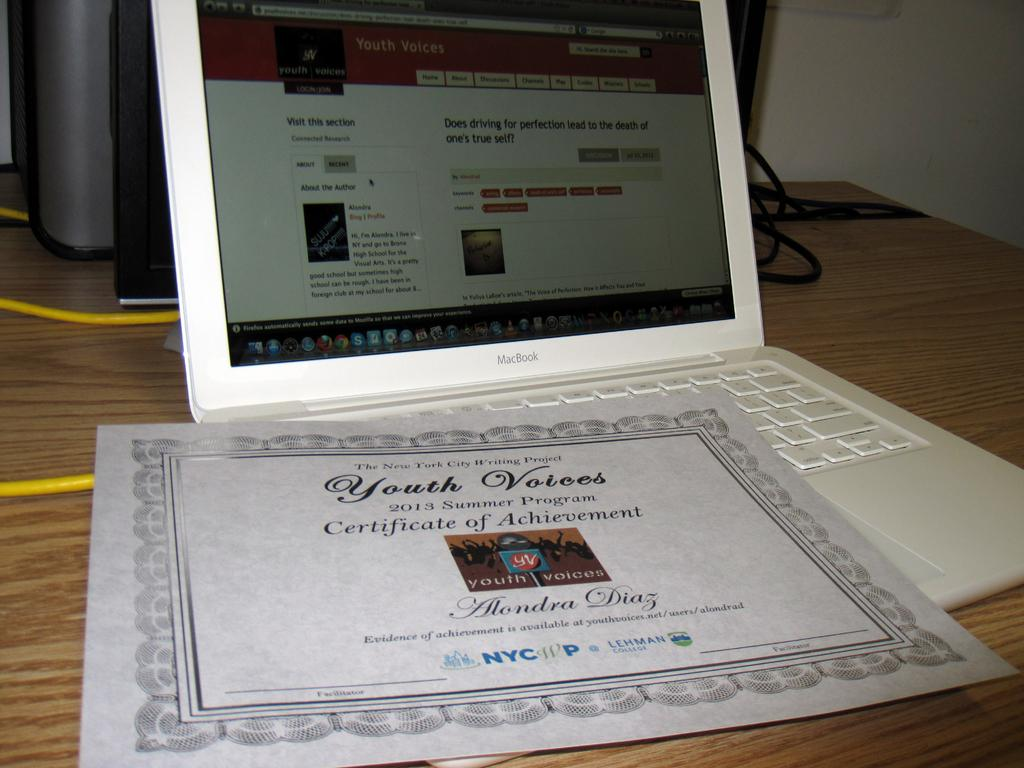<image>
Provide a brief description of the given image. a laptop with a certificate of achievement placed on top of it 